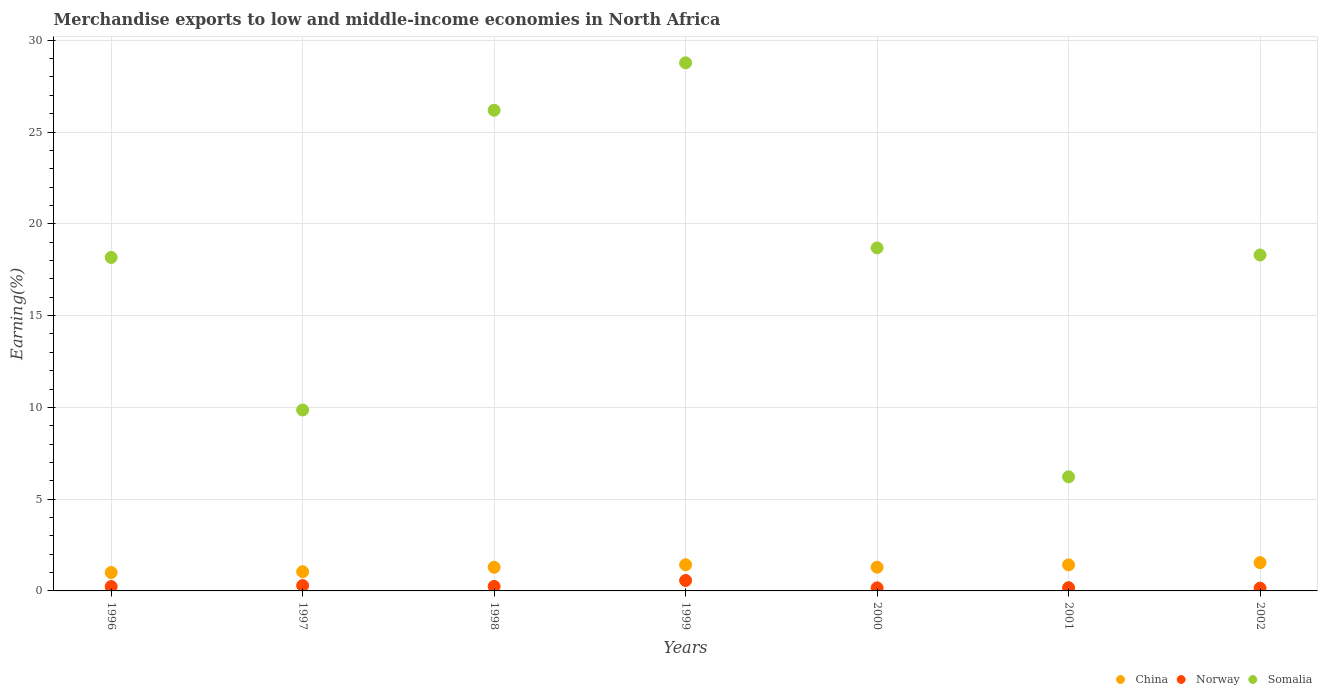How many different coloured dotlines are there?
Provide a short and direct response. 3. Is the number of dotlines equal to the number of legend labels?
Provide a succinct answer. Yes. What is the percentage of amount earned from merchandise exports in Somalia in 2001?
Your answer should be compact. 6.22. Across all years, what is the maximum percentage of amount earned from merchandise exports in Norway?
Your response must be concise. 0.57. Across all years, what is the minimum percentage of amount earned from merchandise exports in Norway?
Make the answer very short. 0.15. In which year was the percentage of amount earned from merchandise exports in China maximum?
Your answer should be compact. 2002. In which year was the percentage of amount earned from merchandise exports in Norway minimum?
Offer a very short reply. 2002. What is the total percentage of amount earned from merchandise exports in Norway in the graph?
Keep it short and to the point. 1.84. What is the difference between the percentage of amount earned from merchandise exports in Somalia in 1996 and that in 2001?
Offer a terse response. 11.95. What is the difference between the percentage of amount earned from merchandise exports in China in 1998 and the percentage of amount earned from merchandise exports in Somalia in 1996?
Your answer should be very brief. -16.88. What is the average percentage of amount earned from merchandise exports in Somalia per year?
Offer a terse response. 18.03. In the year 1999, what is the difference between the percentage of amount earned from merchandise exports in Somalia and percentage of amount earned from merchandise exports in Norway?
Provide a succinct answer. 28.2. In how many years, is the percentage of amount earned from merchandise exports in Somalia greater than 28 %?
Give a very brief answer. 1. What is the ratio of the percentage of amount earned from merchandise exports in China in 1999 to that in 2002?
Provide a short and direct response. 0.92. What is the difference between the highest and the second highest percentage of amount earned from merchandise exports in China?
Make the answer very short. 0.12. What is the difference between the highest and the lowest percentage of amount earned from merchandise exports in China?
Your answer should be very brief. 0.54. Is the sum of the percentage of amount earned from merchandise exports in China in 1999 and 2002 greater than the maximum percentage of amount earned from merchandise exports in Norway across all years?
Your response must be concise. Yes. Is it the case that in every year, the sum of the percentage of amount earned from merchandise exports in Norway and percentage of amount earned from merchandise exports in China  is greater than the percentage of amount earned from merchandise exports in Somalia?
Offer a terse response. No. Is the percentage of amount earned from merchandise exports in Norway strictly less than the percentage of amount earned from merchandise exports in China over the years?
Make the answer very short. Yes. How many dotlines are there?
Provide a succinct answer. 3. Does the graph contain any zero values?
Your answer should be very brief. No. Where does the legend appear in the graph?
Keep it short and to the point. Bottom right. How many legend labels are there?
Make the answer very short. 3. What is the title of the graph?
Your answer should be compact. Merchandise exports to low and middle-income economies in North Africa. Does "Vietnam" appear as one of the legend labels in the graph?
Provide a short and direct response. No. What is the label or title of the Y-axis?
Give a very brief answer. Earning(%). What is the Earning(%) in China in 1996?
Make the answer very short. 1. What is the Earning(%) of Norway in 1996?
Provide a succinct answer. 0.24. What is the Earning(%) of Somalia in 1996?
Your answer should be compact. 18.17. What is the Earning(%) of China in 1997?
Give a very brief answer. 1.05. What is the Earning(%) in Norway in 1997?
Keep it short and to the point. 0.29. What is the Earning(%) of Somalia in 1997?
Provide a short and direct response. 9.86. What is the Earning(%) in China in 1998?
Keep it short and to the point. 1.29. What is the Earning(%) in Norway in 1998?
Offer a terse response. 0.25. What is the Earning(%) of Somalia in 1998?
Offer a terse response. 26.19. What is the Earning(%) in China in 1999?
Make the answer very short. 1.42. What is the Earning(%) in Norway in 1999?
Make the answer very short. 0.57. What is the Earning(%) in Somalia in 1999?
Offer a terse response. 28.77. What is the Earning(%) of China in 2000?
Give a very brief answer. 1.29. What is the Earning(%) in Norway in 2000?
Offer a very short reply. 0.17. What is the Earning(%) of Somalia in 2000?
Give a very brief answer. 18.69. What is the Earning(%) in China in 2001?
Give a very brief answer. 1.42. What is the Earning(%) in Norway in 2001?
Give a very brief answer. 0.18. What is the Earning(%) in Somalia in 2001?
Make the answer very short. 6.22. What is the Earning(%) of China in 2002?
Provide a succinct answer. 1.54. What is the Earning(%) in Norway in 2002?
Offer a terse response. 0.15. What is the Earning(%) of Somalia in 2002?
Your response must be concise. 18.3. Across all years, what is the maximum Earning(%) in China?
Offer a terse response. 1.54. Across all years, what is the maximum Earning(%) of Norway?
Keep it short and to the point. 0.57. Across all years, what is the maximum Earning(%) of Somalia?
Provide a short and direct response. 28.77. Across all years, what is the minimum Earning(%) in China?
Your answer should be compact. 1. Across all years, what is the minimum Earning(%) in Norway?
Your answer should be compact. 0.15. Across all years, what is the minimum Earning(%) of Somalia?
Ensure brevity in your answer.  6.22. What is the total Earning(%) in China in the graph?
Provide a succinct answer. 9.02. What is the total Earning(%) of Norway in the graph?
Give a very brief answer. 1.84. What is the total Earning(%) of Somalia in the graph?
Keep it short and to the point. 126.18. What is the difference between the Earning(%) in China in 1996 and that in 1997?
Offer a terse response. -0.04. What is the difference between the Earning(%) of Norway in 1996 and that in 1997?
Your answer should be very brief. -0.05. What is the difference between the Earning(%) in Somalia in 1996 and that in 1997?
Give a very brief answer. 8.31. What is the difference between the Earning(%) of China in 1996 and that in 1998?
Offer a very short reply. -0.29. What is the difference between the Earning(%) in Norway in 1996 and that in 1998?
Give a very brief answer. -0.01. What is the difference between the Earning(%) in Somalia in 1996 and that in 1998?
Your answer should be very brief. -8.02. What is the difference between the Earning(%) of China in 1996 and that in 1999?
Offer a terse response. -0.42. What is the difference between the Earning(%) of Norway in 1996 and that in 1999?
Offer a terse response. -0.33. What is the difference between the Earning(%) in Somalia in 1996 and that in 1999?
Make the answer very short. -10.6. What is the difference between the Earning(%) of China in 1996 and that in 2000?
Your answer should be very brief. -0.29. What is the difference between the Earning(%) in Norway in 1996 and that in 2000?
Your answer should be very brief. 0.07. What is the difference between the Earning(%) of Somalia in 1996 and that in 2000?
Your answer should be compact. -0.52. What is the difference between the Earning(%) in China in 1996 and that in 2001?
Make the answer very short. -0.42. What is the difference between the Earning(%) of Norway in 1996 and that in 2001?
Ensure brevity in your answer.  0.06. What is the difference between the Earning(%) of Somalia in 1996 and that in 2001?
Offer a terse response. 11.95. What is the difference between the Earning(%) in China in 1996 and that in 2002?
Provide a succinct answer. -0.54. What is the difference between the Earning(%) in Norway in 1996 and that in 2002?
Make the answer very short. 0.08. What is the difference between the Earning(%) of Somalia in 1996 and that in 2002?
Make the answer very short. -0.13. What is the difference between the Earning(%) of China in 1997 and that in 1998?
Your answer should be compact. -0.24. What is the difference between the Earning(%) in Norway in 1997 and that in 1998?
Offer a terse response. 0.05. What is the difference between the Earning(%) of Somalia in 1997 and that in 1998?
Your answer should be very brief. -16.33. What is the difference between the Earning(%) of China in 1997 and that in 1999?
Make the answer very short. -0.38. What is the difference between the Earning(%) in Norway in 1997 and that in 1999?
Provide a succinct answer. -0.28. What is the difference between the Earning(%) in Somalia in 1997 and that in 1999?
Offer a very short reply. -18.91. What is the difference between the Earning(%) of China in 1997 and that in 2000?
Offer a very short reply. -0.25. What is the difference between the Earning(%) in Norway in 1997 and that in 2000?
Offer a terse response. 0.12. What is the difference between the Earning(%) in Somalia in 1997 and that in 2000?
Make the answer very short. -8.83. What is the difference between the Earning(%) in China in 1997 and that in 2001?
Ensure brevity in your answer.  -0.37. What is the difference between the Earning(%) in Norway in 1997 and that in 2001?
Your answer should be compact. 0.11. What is the difference between the Earning(%) in Somalia in 1997 and that in 2001?
Keep it short and to the point. 3.64. What is the difference between the Earning(%) of China in 1997 and that in 2002?
Offer a very short reply. -0.49. What is the difference between the Earning(%) in Norway in 1997 and that in 2002?
Give a very brief answer. 0.14. What is the difference between the Earning(%) of Somalia in 1997 and that in 2002?
Ensure brevity in your answer.  -8.44. What is the difference between the Earning(%) in China in 1998 and that in 1999?
Your answer should be compact. -0.14. What is the difference between the Earning(%) of Norway in 1998 and that in 1999?
Ensure brevity in your answer.  -0.32. What is the difference between the Earning(%) in Somalia in 1998 and that in 1999?
Offer a very short reply. -2.58. What is the difference between the Earning(%) in China in 1998 and that in 2000?
Provide a short and direct response. -0. What is the difference between the Earning(%) in Norway in 1998 and that in 2000?
Your answer should be very brief. 0.08. What is the difference between the Earning(%) of Somalia in 1998 and that in 2000?
Offer a very short reply. 7.5. What is the difference between the Earning(%) in China in 1998 and that in 2001?
Keep it short and to the point. -0.13. What is the difference between the Earning(%) of Norway in 1998 and that in 2001?
Ensure brevity in your answer.  0.07. What is the difference between the Earning(%) in Somalia in 1998 and that in 2001?
Offer a very short reply. 19.97. What is the difference between the Earning(%) in China in 1998 and that in 2002?
Provide a succinct answer. -0.25. What is the difference between the Earning(%) of Norway in 1998 and that in 2002?
Ensure brevity in your answer.  0.09. What is the difference between the Earning(%) of Somalia in 1998 and that in 2002?
Keep it short and to the point. 7.89. What is the difference between the Earning(%) of China in 1999 and that in 2000?
Offer a very short reply. 0.13. What is the difference between the Earning(%) of Norway in 1999 and that in 2000?
Provide a succinct answer. 0.4. What is the difference between the Earning(%) of Somalia in 1999 and that in 2000?
Provide a succinct answer. 10.08. What is the difference between the Earning(%) of China in 1999 and that in 2001?
Make the answer very short. 0. What is the difference between the Earning(%) in Norway in 1999 and that in 2001?
Offer a very short reply. 0.39. What is the difference between the Earning(%) of Somalia in 1999 and that in 2001?
Offer a terse response. 22.55. What is the difference between the Earning(%) in China in 1999 and that in 2002?
Keep it short and to the point. -0.12. What is the difference between the Earning(%) in Norway in 1999 and that in 2002?
Keep it short and to the point. 0.42. What is the difference between the Earning(%) of Somalia in 1999 and that in 2002?
Keep it short and to the point. 10.47. What is the difference between the Earning(%) in China in 2000 and that in 2001?
Ensure brevity in your answer.  -0.13. What is the difference between the Earning(%) of Norway in 2000 and that in 2001?
Ensure brevity in your answer.  -0.01. What is the difference between the Earning(%) of Somalia in 2000 and that in 2001?
Your answer should be very brief. 12.47. What is the difference between the Earning(%) in China in 2000 and that in 2002?
Make the answer very short. -0.25. What is the difference between the Earning(%) of Norway in 2000 and that in 2002?
Offer a very short reply. 0.01. What is the difference between the Earning(%) in Somalia in 2000 and that in 2002?
Provide a short and direct response. 0.39. What is the difference between the Earning(%) in China in 2001 and that in 2002?
Ensure brevity in your answer.  -0.12. What is the difference between the Earning(%) in Norway in 2001 and that in 2002?
Offer a very short reply. 0.02. What is the difference between the Earning(%) in Somalia in 2001 and that in 2002?
Your answer should be compact. -12.08. What is the difference between the Earning(%) in China in 1996 and the Earning(%) in Norway in 1997?
Offer a very short reply. 0.71. What is the difference between the Earning(%) of China in 1996 and the Earning(%) of Somalia in 1997?
Your answer should be very brief. -8.85. What is the difference between the Earning(%) in Norway in 1996 and the Earning(%) in Somalia in 1997?
Provide a succinct answer. -9.62. What is the difference between the Earning(%) in China in 1996 and the Earning(%) in Norway in 1998?
Ensure brevity in your answer.  0.76. What is the difference between the Earning(%) of China in 1996 and the Earning(%) of Somalia in 1998?
Keep it short and to the point. -25.18. What is the difference between the Earning(%) of Norway in 1996 and the Earning(%) of Somalia in 1998?
Ensure brevity in your answer.  -25.95. What is the difference between the Earning(%) of China in 1996 and the Earning(%) of Norway in 1999?
Provide a succinct answer. 0.43. What is the difference between the Earning(%) in China in 1996 and the Earning(%) in Somalia in 1999?
Your answer should be very brief. -27.77. What is the difference between the Earning(%) of Norway in 1996 and the Earning(%) of Somalia in 1999?
Provide a succinct answer. -28.53. What is the difference between the Earning(%) in China in 1996 and the Earning(%) in Norway in 2000?
Offer a very short reply. 0.84. What is the difference between the Earning(%) of China in 1996 and the Earning(%) of Somalia in 2000?
Ensure brevity in your answer.  -17.68. What is the difference between the Earning(%) in Norway in 1996 and the Earning(%) in Somalia in 2000?
Your answer should be very brief. -18.45. What is the difference between the Earning(%) in China in 1996 and the Earning(%) in Norway in 2001?
Offer a terse response. 0.83. What is the difference between the Earning(%) in China in 1996 and the Earning(%) in Somalia in 2001?
Keep it short and to the point. -5.21. What is the difference between the Earning(%) of Norway in 1996 and the Earning(%) of Somalia in 2001?
Give a very brief answer. -5.98. What is the difference between the Earning(%) in China in 1996 and the Earning(%) in Norway in 2002?
Offer a terse response. 0.85. What is the difference between the Earning(%) of China in 1996 and the Earning(%) of Somalia in 2002?
Provide a succinct answer. -17.3. What is the difference between the Earning(%) of Norway in 1996 and the Earning(%) of Somalia in 2002?
Your answer should be compact. -18.06. What is the difference between the Earning(%) of China in 1997 and the Earning(%) of Norway in 1998?
Make the answer very short. 0.8. What is the difference between the Earning(%) in China in 1997 and the Earning(%) in Somalia in 1998?
Offer a terse response. -25.14. What is the difference between the Earning(%) of Norway in 1997 and the Earning(%) of Somalia in 1998?
Ensure brevity in your answer.  -25.9. What is the difference between the Earning(%) of China in 1997 and the Earning(%) of Norway in 1999?
Your answer should be compact. 0.48. What is the difference between the Earning(%) of China in 1997 and the Earning(%) of Somalia in 1999?
Provide a succinct answer. -27.72. What is the difference between the Earning(%) in Norway in 1997 and the Earning(%) in Somalia in 1999?
Give a very brief answer. -28.48. What is the difference between the Earning(%) of China in 1997 and the Earning(%) of Norway in 2000?
Provide a short and direct response. 0.88. What is the difference between the Earning(%) of China in 1997 and the Earning(%) of Somalia in 2000?
Offer a terse response. -17.64. What is the difference between the Earning(%) in Norway in 1997 and the Earning(%) in Somalia in 2000?
Offer a terse response. -18.4. What is the difference between the Earning(%) in China in 1997 and the Earning(%) in Norway in 2001?
Your response must be concise. 0.87. What is the difference between the Earning(%) of China in 1997 and the Earning(%) of Somalia in 2001?
Your answer should be very brief. -5.17. What is the difference between the Earning(%) in Norway in 1997 and the Earning(%) in Somalia in 2001?
Your answer should be compact. -5.92. What is the difference between the Earning(%) in China in 1997 and the Earning(%) in Norway in 2002?
Your answer should be compact. 0.89. What is the difference between the Earning(%) in China in 1997 and the Earning(%) in Somalia in 2002?
Your answer should be compact. -17.25. What is the difference between the Earning(%) of Norway in 1997 and the Earning(%) of Somalia in 2002?
Offer a very short reply. -18.01. What is the difference between the Earning(%) of China in 1998 and the Earning(%) of Norway in 1999?
Make the answer very short. 0.72. What is the difference between the Earning(%) in China in 1998 and the Earning(%) in Somalia in 1999?
Keep it short and to the point. -27.48. What is the difference between the Earning(%) of Norway in 1998 and the Earning(%) of Somalia in 1999?
Give a very brief answer. -28.52. What is the difference between the Earning(%) of China in 1998 and the Earning(%) of Norway in 2000?
Make the answer very short. 1.12. What is the difference between the Earning(%) of China in 1998 and the Earning(%) of Somalia in 2000?
Give a very brief answer. -17.4. What is the difference between the Earning(%) in Norway in 1998 and the Earning(%) in Somalia in 2000?
Your answer should be compact. -18.44. What is the difference between the Earning(%) in China in 1998 and the Earning(%) in Norway in 2001?
Ensure brevity in your answer.  1.11. What is the difference between the Earning(%) in China in 1998 and the Earning(%) in Somalia in 2001?
Make the answer very short. -4.93. What is the difference between the Earning(%) of Norway in 1998 and the Earning(%) of Somalia in 2001?
Your response must be concise. -5.97. What is the difference between the Earning(%) in China in 1998 and the Earning(%) in Norway in 2002?
Give a very brief answer. 1.14. What is the difference between the Earning(%) of China in 1998 and the Earning(%) of Somalia in 2002?
Your response must be concise. -17.01. What is the difference between the Earning(%) of Norway in 1998 and the Earning(%) of Somalia in 2002?
Provide a succinct answer. -18.05. What is the difference between the Earning(%) of China in 1999 and the Earning(%) of Norway in 2000?
Offer a very short reply. 1.26. What is the difference between the Earning(%) of China in 1999 and the Earning(%) of Somalia in 2000?
Provide a succinct answer. -17.26. What is the difference between the Earning(%) in Norway in 1999 and the Earning(%) in Somalia in 2000?
Provide a succinct answer. -18.12. What is the difference between the Earning(%) of China in 1999 and the Earning(%) of Norway in 2001?
Provide a short and direct response. 1.25. What is the difference between the Earning(%) of China in 1999 and the Earning(%) of Somalia in 2001?
Your answer should be compact. -4.79. What is the difference between the Earning(%) in Norway in 1999 and the Earning(%) in Somalia in 2001?
Offer a very short reply. -5.65. What is the difference between the Earning(%) of China in 1999 and the Earning(%) of Norway in 2002?
Ensure brevity in your answer.  1.27. What is the difference between the Earning(%) of China in 1999 and the Earning(%) of Somalia in 2002?
Offer a very short reply. -16.88. What is the difference between the Earning(%) of Norway in 1999 and the Earning(%) of Somalia in 2002?
Offer a very short reply. -17.73. What is the difference between the Earning(%) of China in 2000 and the Earning(%) of Norway in 2001?
Provide a short and direct response. 1.12. What is the difference between the Earning(%) of China in 2000 and the Earning(%) of Somalia in 2001?
Your answer should be compact. -4.92. What is the difference between the Earning(%) of Norway in 2000 and the Earning(%) of Somalia in 2001?
Provide a short and direct response. -6.05. What is the difference between the Earning(%) in China in 2000 and the Earning(%) in Norway in 2002?
Offer a very short reply. 1.14. What is the difference between the Earning(%) in China in 2000 and the Earning(%) in Somalia in 2002?
Keep it short and to the point. -17.01. What is the difference between the Earning(%) in Norway in 2000 and the Earning(%) in Somalia in 2002?
Your answer should be very brief. -18.13. What is the difference between the Earning(%) in China in 2001 and the Earning(%) in Norway in 2002?
Make the answer very short. 1.27. What is the difference between the Earning(%) in China in 2001 and the Earning(%) in Somalia in 2002?
Ensure brevity in your answer.  -16.88. What is the difference between the Earning(%) in Norway in 2001 and the Earning(%) in Somalia in 2002?
Keep it short and to the point. -18.12. What is the average Earning(%) in China per year?
Your answer should be compact. 1.29. What is the average Earning(%) of Norway per year?
Offer a very short reply. 0.26. What is the average Earning(%) in Somalia per year?
Offer a terse response. 18.03. In the year 1996, what is the difference between the Earning(%) of China and Earning(%) of Norway?
Make the answer very short. 0.77. In the year 1996, what is the difference between the Earning(%) in China and Earning(%) in Somalia?
Keep it short and to the point. -17.17. In the year 1996, what is the difference between the Earning(%) of Norway and Earning(%) of Somalia?
Your answer should be compact. -17.93. In the year 1997, what is the difference between the Earning(%) of China and Earning(%) of Norway?
Offer a terse response. 0.76. In the year 1997, what is the difference between the Earning(%) of China and Earning(%) of Somalia?
Provide a succinct answer. -8.81. In the year 1997, what is the difference between the Earning(%) in Norway and Earning(%) in Somalia?
Offer a very short reply. -9.57. In the year 1998, what is the difference between the Earning(%) of China and Earning(%) of Norway?
Your answer should be very brief. 1.04. In the year 1998, what is the difference between the Earning(%) in China and Earning(%) in Somalia?
Keep it short and to the point. -24.9. In the year 1998, what is the difference between the Earning(%) in Norway and Earning(%) in Somalia?
Offer a very short reply. -25.94. In the year 1999, what is the difference between the Earning(%) in China and Earning(%) in Norway?
Offer a very short reply. 0.86. In the year 1999, what is the difference between the Earning(%) in China and Earning(%) in Somalia?
Provide a short and direct response. -27.34. In the year 1999, what is the difference between the Earning(%) in Norway and Earning(%) in Somalia?
Provide a short and direct response. -28.2. In the year 2000, what is the difference between the Earning(%) in China and Earning(%) in Norway?
Give a very brief answer. 1.12. In the year 2000, what is the difference between the Earning(%) of China and Earning(%) of Somalia?
Offer a terse response. -17.39. In the year 2000, what is the difference between the Earning(%) in Norway and Earning(%) in Somalia?
Your response must be concise. -18.52. In the year 2001, what is the difference between the Earning(%) in China and Earning(%) in Norway?
Make the answer very short. 1.24. In the year 2001, what is the difference between the Earning(%) in China and Earning(%) in Somalia?
Your answer should be very brief. -4.8. In the year 2001, what is the difference between the Earning(%) in Norway and Earning(%) in Somalia?
Ensure brevity in your answer.  -6.04. In the year 2002, what is the difference between the Earning(%) of China and Earning(%) of Norway?
Give a very brief answer. 1.39. In the year 2002, what is the difference between the Earning(%) in China and Earning(%) in Somalia?
Ensure brevity in your answer.  -16.76. In the year 2002, what is the difference between the Earning(%) of Norway and Earning(%) of Somalia?
Your response must be concise. -18.15. What is the ratio of the Earning(%) of China in 1996 to that in 1997?
Make the answer very short. 0.96. What is the ratio of the Earning(%) of Norway in 1996 to that in 1997?
Provide a short and direct response. 0.82. What is the ratio of the Earning(%) in Somalia in 1996 to that in 1997?
Give a very brief answer. 1.84. What is the ratio of the Earning(%) in China in 1996 to that in 1998?
Your response must be concise. 0.78. What is the ratio of the Earning(%) in Norway in 1996 to that in 1998?
Give a very brief answer. 0.97. What is the ratio of the Earning(%) of Somalia in 1996 to that in 1998?
Keep it short and to the point. 0.69. What is the ratio of the Earning(%) in China in 1996 to that in 1999?
Your answer should be compact. 0.7. What is the ratio of the Earning(%) of Norway in 1996 to that in 1999?
Keep it short and to the point. 0.42. What is the ratio of the Earning(%) of Somalia in 1996 to that in 1999?
Provide a succinct answer. 0.63. What is the ratio of the Earning(%) in China in 1996 to that in 2000?
Give a very brief answer. 0.78. What is the ratio of the Earning(%) of Norway in 1996 to that in 2000?
Offer a terse response. 1.42. What is the ratio of the Earning(%) in Somalia in 1996 to that in 2000?
Your response must be concise. 0.97. What is the ratio of the Earning(%) in China in 1996 to that in 2001?
Give a very brief answer. 0.71. What is the ratio of the Earning(%) in Norway in 1996 to that in 2001?
Provide a succinct answer. 1.34. What is the ratio of the Earning(%) of Somalia in 1996 to that in 2001?
Your response must be concise. 2.92. What is the ratio of the Earning(%) in China in 1996 to that in 2002?
Provide a short and direct response. 0.65. What is the ratio of the Earning(%) of Norway in 1996 to that in 2002?
Offer a terse response. 1.56. What is the ratio of the Earning(%) of China in 1997 to that in 1998?
Offer a terse response. 0.81. What is the ratio of the Earning(%) in Norway in 1997 to that in 1998?
Provide a succinct answer. 1.19. What is the ratio of the Earning(%) in Somalia in 1997 to that in 1998?
Your answer should be compact. 0.38. What is the ratio of the Earning(%) of China in 1997 to that in 1999?
Your answer should be very brief. 0.73. What is the ratio of the Earning(%) in Norway in 1997 to that in 1999?
Offer a terse response. 0.51. What is the ratio of the Earning(%) in Somalia in 1997 to that in 1999?
Provide a succinct answer. 0.34. What is the ratio of the Earning(%) of China in 1997 to that in 2000?
Give a very brief answer. 0.81. What is the ratio of the Earning(%) in Norway in 1997 to that in 2000?
Provide a succinct answer. 1.74. What is the ratio of the Earning(%) of Somalia in 1997 to that in 2000?
Provide a succinct answer. 0.53. What is the ratio of the Earning(%) of China in 1997 to that in 2001?
Provide a succinct answer. 0.74. What is the ratio of the Earning(%) in Norway in 1997 to that in 2001?
Your response must be concise. 1.65. What is the ratio of the Earning(%) of Somalia in 1997 to that in 2001?
Your answer should be very brief. 1.59. What is the ratio of the Earning(%) in China in 1997 to that in 2002?
Provide a succinct answer. 0.68. What is the ratio of the Earning(%) of Norway in 1997 to that in 2002?
Offer a terse response. 1.91. What is the ratio of the Earning(%) of Somalia in 1997 to that in 2002?
Keep it short and to the point. 0.54. What is the ratio of the Earning(%) of China in 1998 to that in 1999?
Offer a very short reply. 0.9. What is the ratio of the Earning(%) of Norway in 1998 to that in 1999?
Offer a terse response. 0.43. What is the ratio of the Earning(%) in Somalia in 1998 to that in 1999?
Your response must be concise. 0.91. What is the ratio of the Earning(%) in Norway in 1998 to that in 2000?
Offer a very short reply. 1.46. What is the ratio of the Earning(%) in Somalia in 1998 to that in 2000?
Ensure brevity in your answer.  1.4. What is the ratio of the Earning(%) in China in 1998 to that in 2001?
Your answer should be compact. 0.91. What is the ratio of the Earning(%) in Norway in 1998 to that in 2001?
Provide a short and direct response. 1.39. What is the ratio of the Earning(%) of Somalia in 1998 to that in 2001?
Your answer should be very brief. 4.21. What is the ratio of the Earning(%) of China in 1998 to that in 2002?
Ensure brevity in your answer.  0.84. What is the ratio of the Earning(%) in Norway in 1998 to that in 2002?
Give a very brief answer. 1.61. What is the ratio of the Earning(%) in Somalia in 1998 to that in 2002?
Ensure brevity in your answer.  1.43. What is the ratio of the Earning(%) in China in 1999 to that in 2000?
Your response must be concise. 1.1. What is the ratio of the Earning(%) in Norway in 1999 to that in 2000?
Your answer should be compact. 3.39. What is the ratio of the Earning(%) in Somalia in 1999 to that in 2000?
Your answer should be compact. 1.54. What is the ratio of the Earning(%) in Norway in 1999 to that in 2001?
Ensure brevity in your answer.  3.22. What is the ratio of the Earning(%) in Somalia in 1999 to that in 2001?
Provide a short and direct response. 4.63. What is the ratio of the Earning(%) of China in 1999 to that in 2002?
Make the answer very short. 0.92. What is the ratio of the Earning(%) of Norway in 1999 to that in 2002?
Give a very brief answer. 3.73. What is the ratio of the Earning(%) of Somalia in 1999 to that in 2002?
Give a very brief answer. 1.57. What is the ratio of the Earning(%) in China in 2000 to that in 2001?
Offer a very short reply. 0.91. What is the ratio of the Earning(%) of Norway in 2000 to that in 2001?
Your answer should be compact. 0.95. What is the ratio of the Earning(%) of Somalia in 2000 to that in 2001?
Your answer should be compact. 3.01. What is the ratio of the Earning(%) in China in 2000 to that in 2002?
Ensure brevity in your answer.  0.84. What is the ratio of the Earning(%) in Norway in 2000 to that in 2002?
Your response must be concise. 1.1. What is the ratio of the Earning(%) of Somalia in 2000 to that in 2002?
Ensure brevity in your answer.  1.02. What is the ratio of the Earning(%) in China in 2001 to that in 2002?
Your answer should be compact. 0.92. What is the ratio of the Earning(%) of Norway in 2001 to that in 2002?
Ensure brevity in your answer.  1.16. What is the ratio of the Earning(%) in Somalia in 2001 to that in 2002?
Your answer should be very brief. 0.34. What is the difference between the highest and the second highest Earning(%) in China?
Give a very brief answer. 0.12. What is the difference between the highest and the second highest Earning(%) of Norway?
Give a very brief answer. 0.28. What is the difference between the highest and the second highest Earning(%) in Somalia?
Your answer should be compact. 2.58. What is the difference between the highest and the lowest Earning(%) in China?
Give a very brief answer. 0.54. What is the difference between the highest and the lowest Earning(%) of Norway?
Make the answer very short. 0.42. What is the difference between the highest and the lowest Earning(%) in Somalia?
Your answer should be compact. 22.55. 